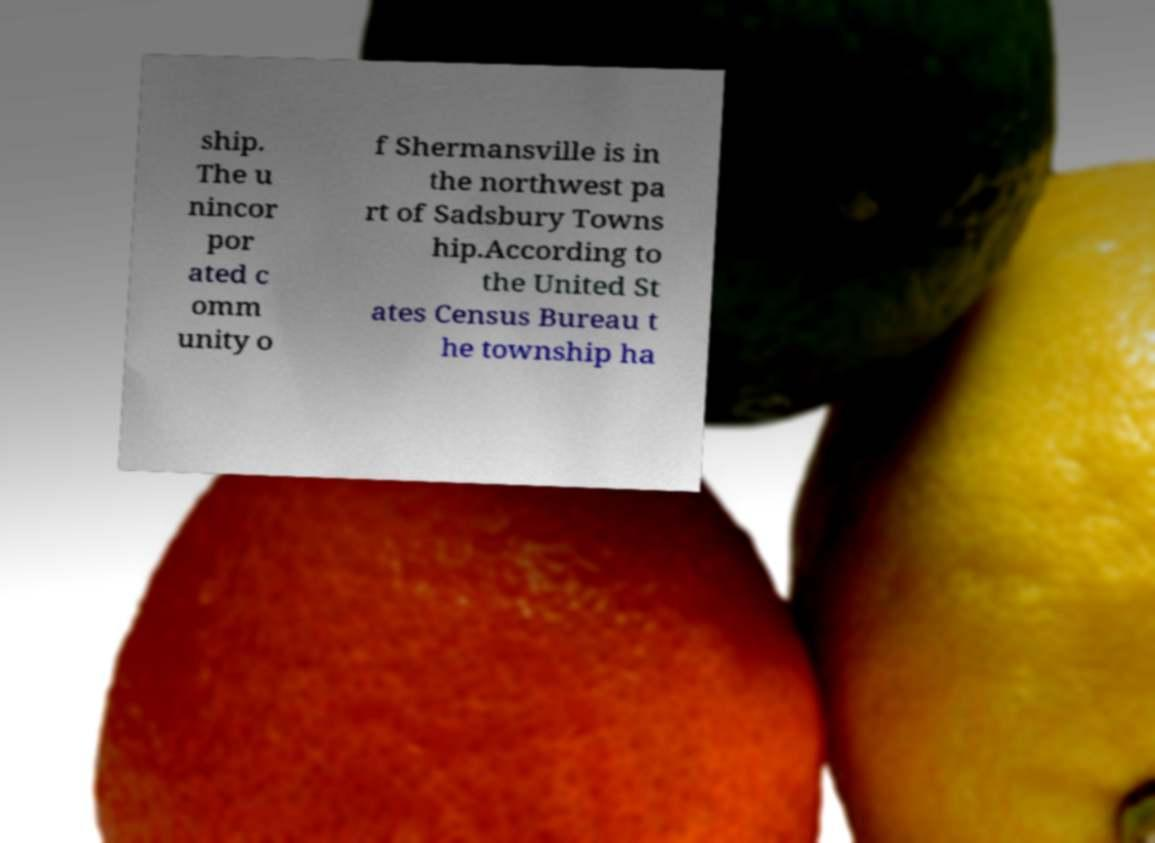I need the written content from this picture converted into text. Can you do that? ship. The u nincor por ated c omm unity o f Shermansville is in the northwest pa rt of Sadsbury Towns hip.According to the United St ates Census Bureau t he township ha 